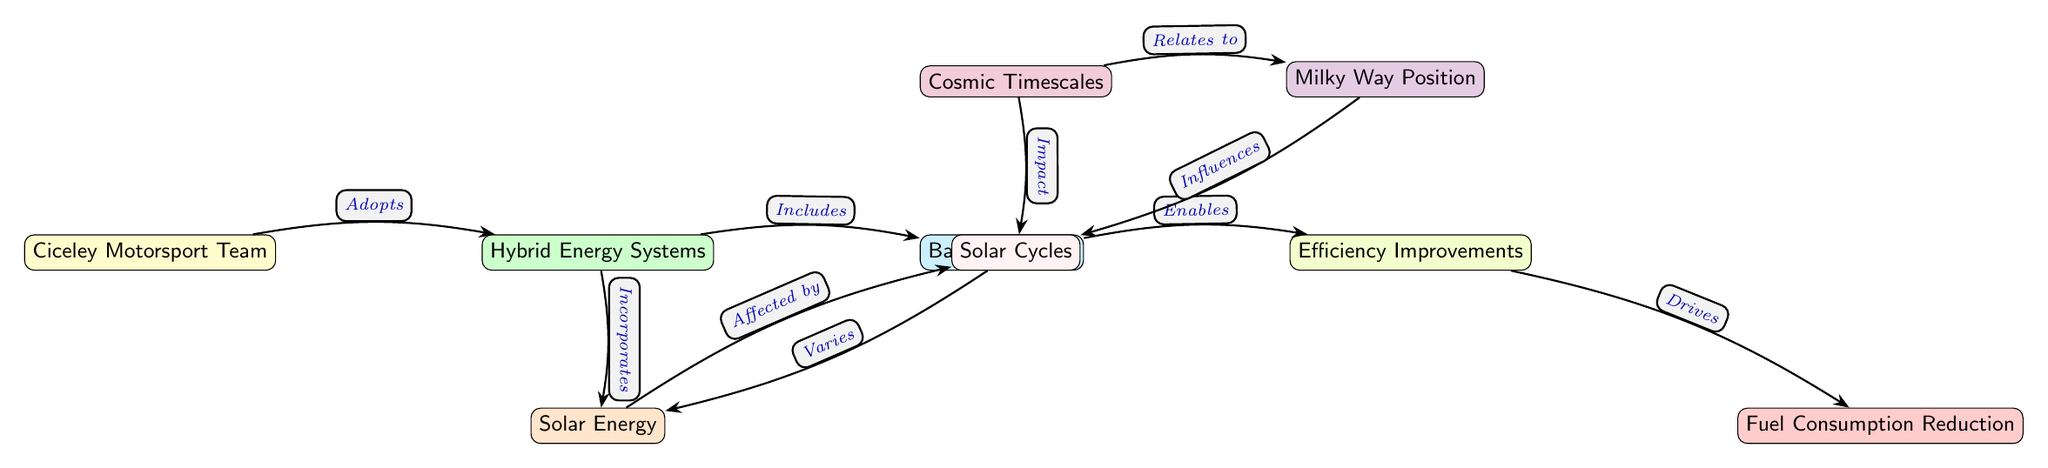What nodes are connected to Hybrid Energy Systems? The diagram shows three nodes connected to Hybrid Energy Systems: Solar Energy, Battery Storage, and Cosmic Timescales. These are the nodes that relate directly to Hybrid Energy Systems, as indicated by the arrows leading to and from it.
Answer: Solar Energy, Battery Storage, Cosmic Timescales What color represents the Ciceley Motorsport Team in the diagram? The Ciceley Motorsport Team is represented by a node filled with yellow color, as marked in the diagram.
Answer: Yellow How many edges are there in the diagram? By counting the lines (edges) that connect the nodes, there are a total of 8 edges represented in the diagram.
Answer: 8 What impact does Cosmic Timescales have on Solar Cycles? Cosmic Timescales has an "Impact" relationship with Solar Cycles, as indicated by the arrow connecting these two nodes in the diagram.
Answer: Impact Which node enables Efficiency Improvements? The node that enables Efficiency Improvements is Battery Storage, as shown by the arrow directing from Battery Storage to Efficiency Improvements in the diagram.
Answer: Battery Storage How does the Milky Way Position influence Solar Cycles? The Milky Way Position influences Solar Cycles through an "Influences" relationship, which is marked by the connecting arrow from Milky Way Position to Solar Cycles in the diagram.
Answer: Influences What effect does Solar Cycles have on Solar Energy? Solar Cycles "Varies" Solar Energy, shown by the directed edge from Solar Cycles to Solar Energy in the diagram.
Answer: Varies What drives Fuel Consumption Reduction in the diagram? Fuel Consumption Reduction is driven by Efficiency Improvements, illustrated by the arrow from Efficiency Improvements to Fuel Consumption Reduction in the diagram.
Answer: Efficiency Improvements Which node incorporates Hybrid Energy Systems? The node that incorporates Hybrid Energy Systems is Solar Energy, as indicated by the arrow pointing from Hybrid Energy Systems to Solar Energy.
Answer: Solar Energy 